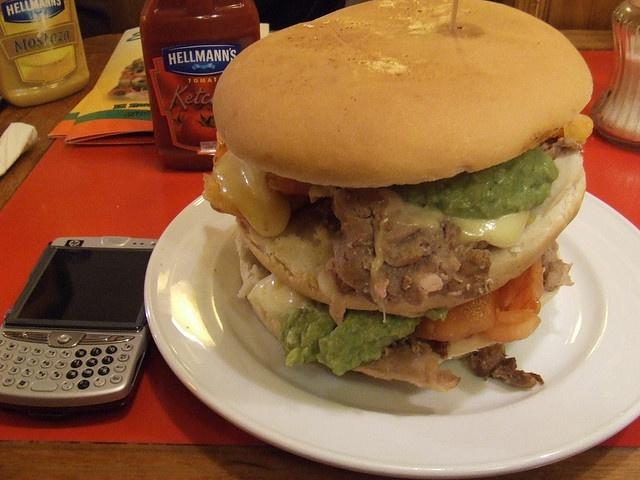Describe the objects in this image and their specific colors. I can see sandwich in maroon, orange, and olive tones, dining table in maroon, brown, black, and red tones, cell phone in maroon, black, and gray tones, bottle in maroon, black, and gray tones, and bottle in olive, maroon, and black tones in this image. 